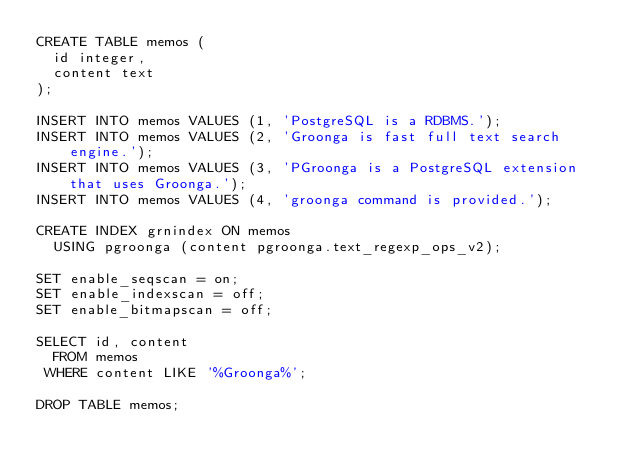Convert code to text. <code><loc_0><loc_0><loc_500><loc_500><_SQL_>CREATE TABLE memos (
  id integer,
  content text
);

INSERT INTO memos VALUES (1, 'PostgreSQL is a RDBMS.');
INSERT INTO memos VALUES (2, 'Groonga is fast full text search engine.');
INSERT INTO memos VALUES (3, 'PGroonga is a PostgreSQL extension that uses Groonga.');
INSERT INTO memos VALUES (4, 'groonga command is provided.');

CREATE INDEX grnindex ON memos
  USING pgroonga (content pgroonga.text_regexp_ops_v2);

SET enable_seqscan = on;
SET enable_indexscan = off;
SET enable_bitmapscan = off;

SELECT id, content
  FROM memos
 WHERE content LIKE '%Groonga%';

DROP TABLE memos;
</code> 